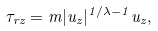Convert formula to latex. <formula><loc_0><loc_0><loc_500><loc_500>\tau _ { r z } = m | u _ { z } | ^ { 1 / \lambda - 1 } u _ { z } ,</formula> 